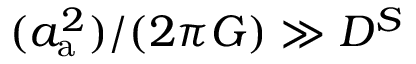<formula> <loc_0><loc_0><loc_500><loc_500>( a _ { a } ^ { 2 } ) / ( 2 \pi G ) \gg D ^ { S }</formula> 